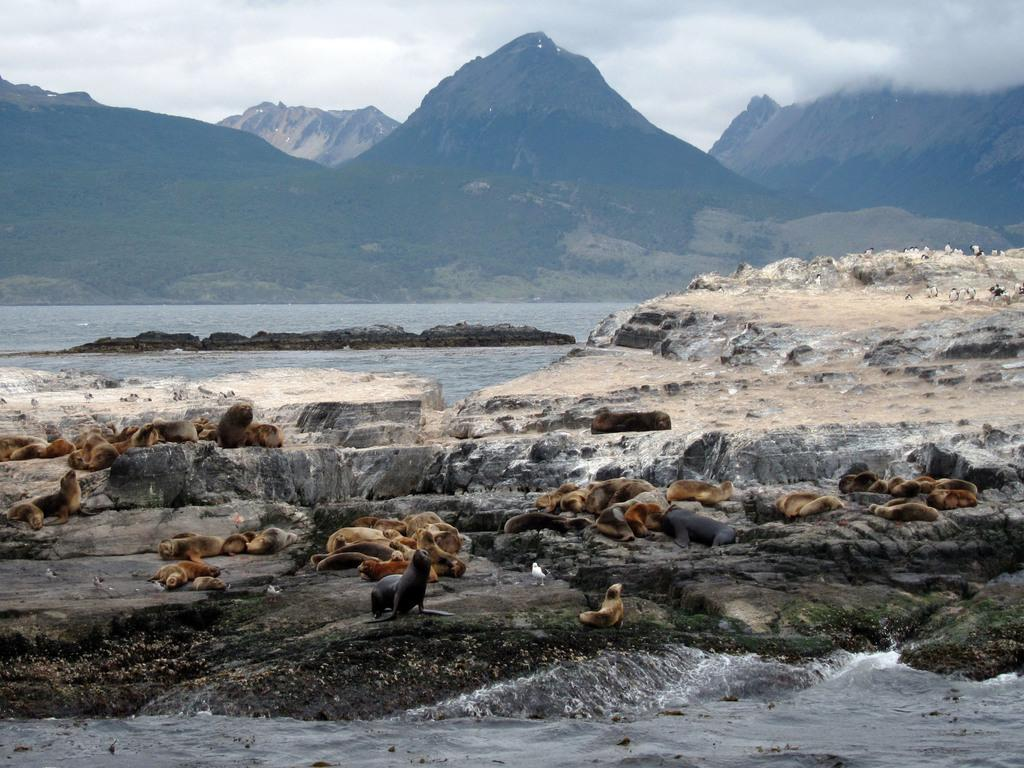What is on the stones in the image? There are animals on the stones in the image. What can be seen in the distance in the image? There are mountains in the background of the image. What is visible besides the stones and mountains? There is water visible in the image. What type of cream can be seen on the animals in the image? There is no cream visible on the animals in the image. What color is the sky in the image? The provided facts do not mention the color of the sky, so we cannot determine its color from the image. 